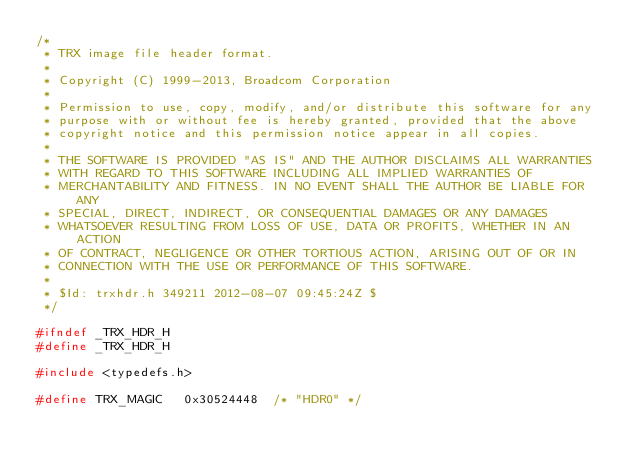<code> <loc_0><loc_0><loc_500><loc_500><_C_>/*
 * TRX image file header format.
 *
 * Copyright (C) 1999-2013, Broadcom Corporation
 *
 * Permission to use, copy, modify, and/or distribute this software for any
 * purpose with or without fee is hereby granted, provided that the above
 * copyright notice and this permission notice appear in all copies.
 *
 * THE SOFTWARE IS PROVIDED "AS IS" AND THE AUTHOR DISCLAIMS ALL WARRANTIES
 * WITH REGARD TO THIS SOFTWARE INCLUDING ALL IMPLIED WARRANTIES OF
 * MERCHANTABILITY AND FITNESS. IN NO EVENT SHALL THE AUTHOR BE LIABLE FOR ANY
 * SPECIAL, DIRECT, INDIRECT, OR CONSEQUENTIAL DAMAGES OR ANY DAMAGES
 * WHATSOEVER RESULTING FROM LOSS OF USE, DATA OR PROFITS, WHETHER IN AN ACTION
 * OF CONTRACT, NEGLIGENCE OR OTHER TORTIOUS ACTION, ARISING OUT OF OR IN
 * CONNECTION WITH THE USE OR PERFORMANCE OF THIS SOFTWARE.
 *
 * $Id: trxhdr.h 349211 2012-08-07 09:45:24Z $
 */

#ifndef _TRX_HDR_H
#define _TRX_HDR_H

#include <typedefs.h>

#define TRX_MAGIC	0x30524448	/* "HDR0" */</code> 